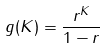<formula> <loc_0><loc_0><loc_500><loc_500>g ( K ) = \frac { r ^ { K } } { 1 - r }</formula> 